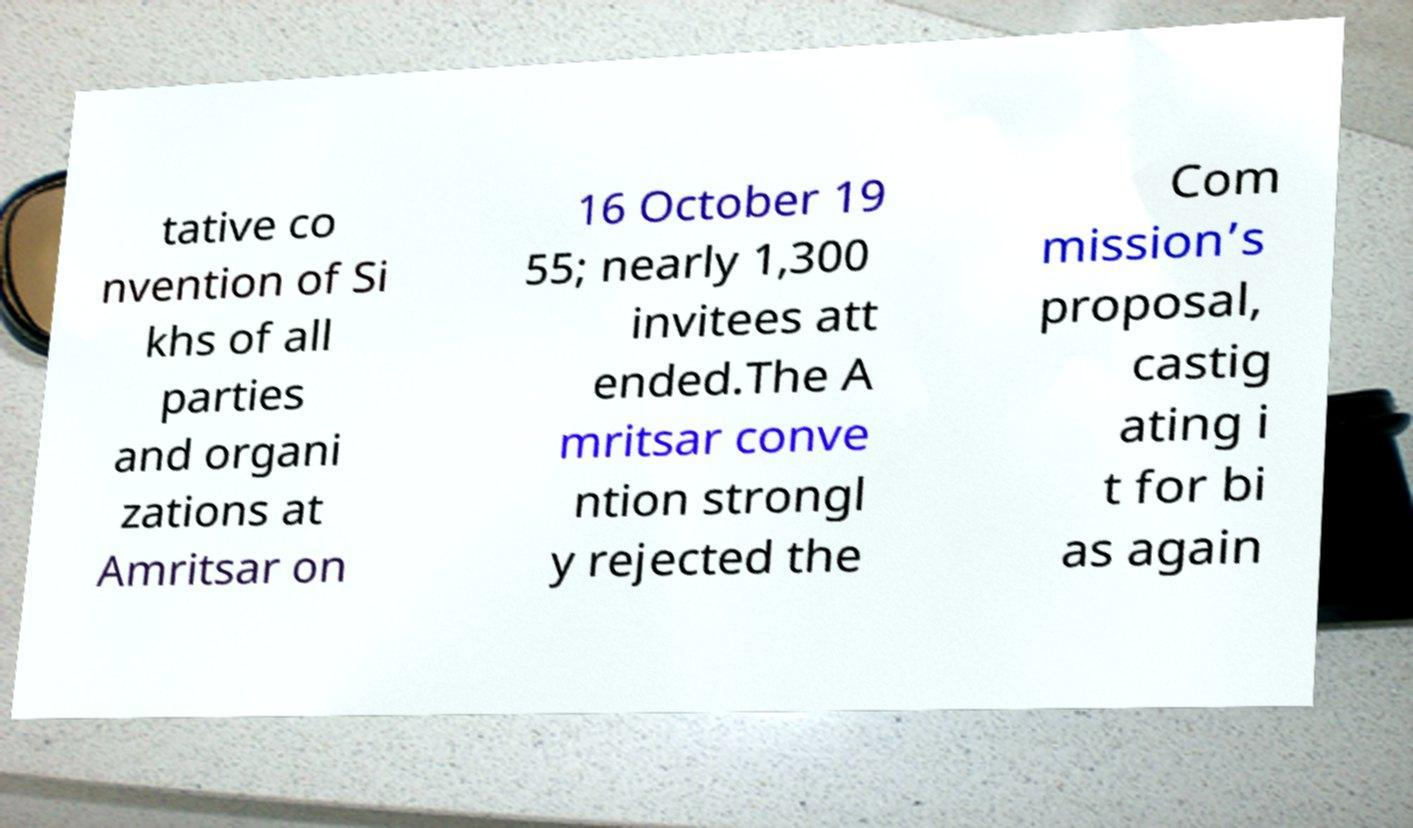Please identify and transcribe the text found in this image. tative co nvention of Si khs of all parties and organi zations at Amritsar on 16 October 19 55; nearly 1,300 invitees att ended.The A mritsar conve ntion strongl y rejected the Com mission’s proposal, castig ating i t for bi as again 